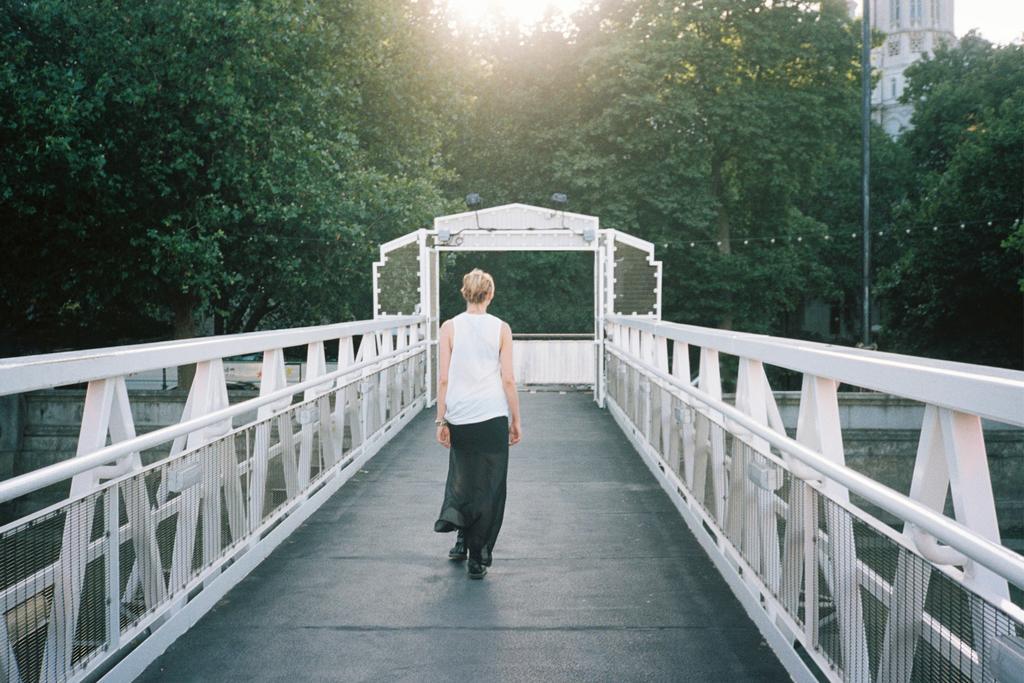Describe this image in one or two sentences. In the middle I can see a person is walking on the bridge. In the background I can see trees, pole, buildings and the sky. This image is taken may be during a day. 